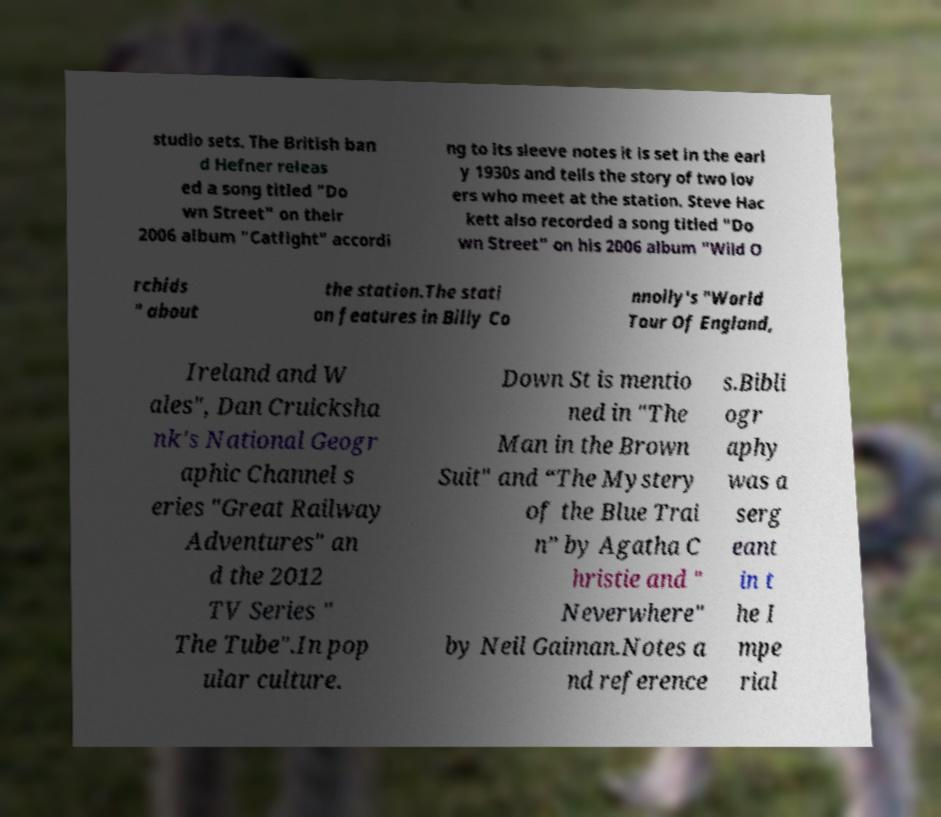There's text embedded in this image that I need extracted. Can you transcribe it verbatim? studio sets. The British ban d Hefner releas ed a song titled "Do wn Street" on their 2006 album "Catfight" accordi ng to its sleeve notes it is set in the earl y 1930s and tells the story of two lov ers who meet at the station. Steve Hac kett also recorded a song titled "Do wn Street" on his 2006 album "Wild O rchids " about the station.The stati on features in Billy Co nnolly's "World Tour Of England, Ireland and W ales", Dan Cruicksha nk's National Geogr aphic Channel s eries "Great Railway Adventures" an d the 2012 TV Series " The Tube".In pop ular culture. Down St is mentio ned in "The Man in the Brown Suit" and “The Mystery of the Blue Trai n” by Agatha C hristie and " Neverwhere" by Neil Gaiman.Notes a nd reference s.Bibli ogr aphy was a serg eant in t he I mpe rial 